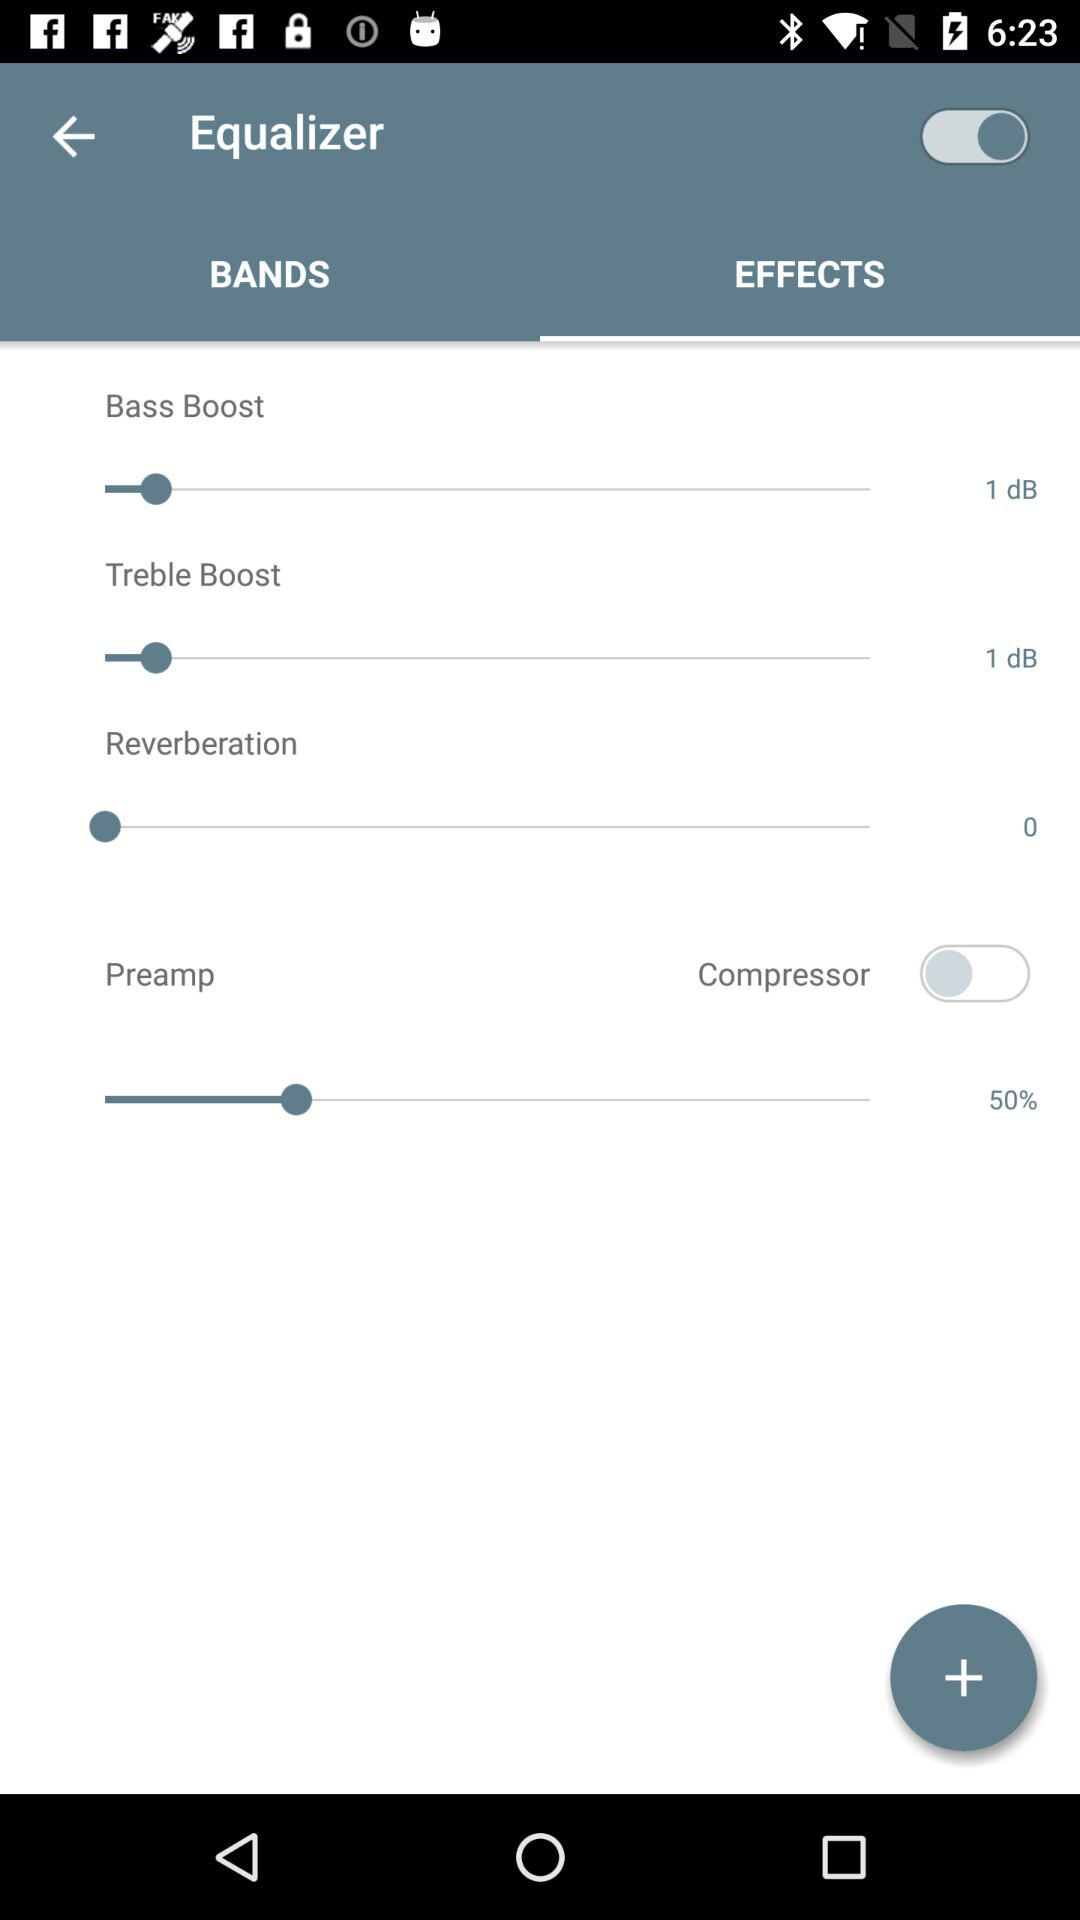How many dB more reverberation is there than bass boost?
Answer the question using a single word or phrase. 1 dB 